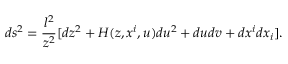Convert formula to latex. <formula><loc_0><loc_0><loc_500><loc_500>d s ^ { 2 } = { \frac { l ^ { 2 } } { z ^ { 2 } } } [ d z ^ { 2 } + H ( z , x ^ { i } , u ) d u ^ { 2 } + d u d v + d x ^ { i } d x _ { i } ] .</formula> 